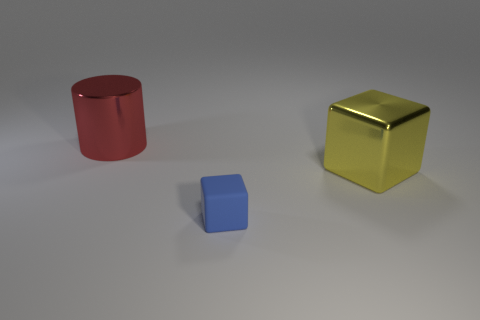What mood or atmosphere do you think the image conveys? The image has a clean and simplistic composition, which may convey a sense of calmness or sterility. The absence of any discernible context or background elements gives it an abstract quality that leaves much to the viewer's interpretation. 